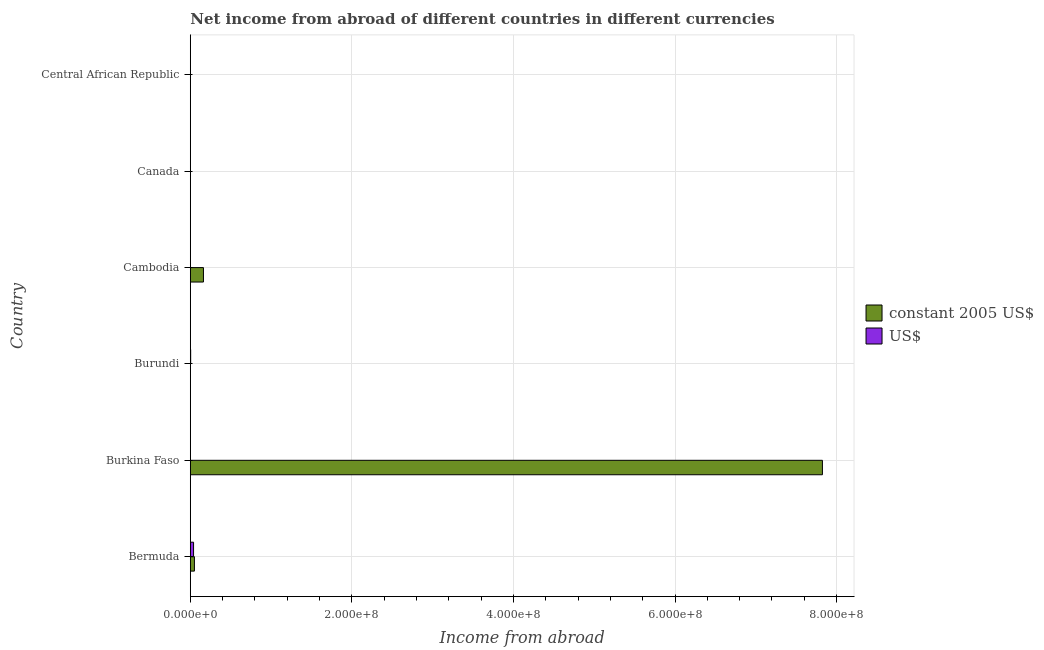Are the number of bars on each tick of the Y-axis equal?
Provide a short and direct response. No. How many bars are there on the 3rd tick from the top?
Provide a succinct answer. 1. What is the income from abroad in us$ in Burundi?
Offer a very short reply. 4.65e+05. Across all countries, what is the maximum income from abroad in constant 2005 us$?
Keep it short and to the point. 7.82e+08. In which country was the income from abroad in us$ maximum?
Provide a short and direct response. Bermuda. What is the total income from abroad in us$ in the graph?
Give a very brief answer. 4.51e+06. What is the difference between the income from abroad in us$ in Bermuda and that in Burundi?
Provide a short and direct response. 3.58e+06. What is the average income from abroad in constant 2005 us$ per country?
Provide a short and direct response. 1.34e+08. What is the difference between the income from abroad in constant 2005 us$ and income from abroad in us$ in Bermuda?
Offer a very short reply. 1.05e+06. What is the difference between the highest and the second highest income from abroad in constant 2005 us$?
Offer a terse response. 7.66e+08. What is the difference between the highest and the lowest income from abroad in us$?
Ensure brevity in your answer.  4.05e+06. Are the values on the major ticks of X-axis written in scientific E-notation?
Your answer should be very brief. Yes. Does the graph contain grids?
Keep it short and to the point. Yes. Where does the legend appear in the graph?
Your answer should be very brief. Center right. What is the title of the graph?
Offer a terse response. Net income from abroad of different countries in different currencies. What is the label or title of the X-axis?
Your answer should be compact. Income from abroad. What is the label or title of the Y-axis?
Your answer should be very brief. Country. What is the Income from abroad in constant 2005 US$ in Bermuda?
Your answer should be very brief. 5.10e+06. What is the Income from abroad of US$ in Bermuda?
Ensure brevity in your answer.  4.05e+06. What is the Income from abroad of constant 2005 US$ in Burkina Faso?
Give a very brief answer. 7.82e+08. What is the Income from abroad in US$ in Burkina Faso?
Offer a very short reply. 0. What is the Income from abroad in constant 2005 US$ in Burundi?
Give a very brief answer. 0. What is the Income from abroad in US$ in Burundi?
Provide a short and direct response. 4.65e+05. What is the Income from abroad in constant 2005 US$ in Cambodia?
Your answer should be very brief. 1.63e+07. What is the Income from abroad of US$ in Cambodia?
Offer a terse response. 0. What is the Income from abroad in constant 2005 US$ in Central African Republic?
Provide a succinct answer. 0. Across all countries, what is the maximum Income from abroad of constant 2005 US$?
Give a very brief answer. 7.82e+08. Across all countries, what is the maximum Income from abroad of US$?
Offer a terse response. 4.05e+06. Across all countries, what is the minimum Income from abroad of constant 2005 US$?
Give a very brief answer. 0. What is the total Income from abroad of constant 2005 US$ in the graph?
Offer a terse response. 8.04e+08. What is the total Income from abroad of US$ in the graph?
Your answer should be compact. 4.51e+06. What is the difference between the Income from abroad of constant 2005 US$ in Bermuda and that in Burkina Faso?
Your answer should be compact. -7.77e+08. What is the difference between the Income from abroad in US$ in Bermuda and that in Burundi?
Keep it short and to the point. 3.58e+06. What is the difference between the Income from abroad in constant 2005 US$ in Bermuda and that in Cambodia?
Provide a short and direct response. -1.12e+07. What is the difference between the Income from abroad in constant 2005 US$ in Burkina Faso and that in Cambodia?
Give a very brief answer. 7.66e+08. What is the difference between the Income from abroad of constant 2005 US$ in Bermuda and the Income from abroad of US$ in Burundi?
Ensure brevity in your answer.  4.63e+06. What is the difference between the Income from abroad in constant 2005 US$ in Burkina Faso and the Income from abroad in US$ in Burundi?
Your answer should be compact. 7.82e+08. What is the average Income from abroad of constant 2005 US$ per country?
Your answer should be very brief. 1.34e+08. What is the average Income from abroad of US$ per country?
Provide a short and direct response. 7.52e+05. What is the difference between the Income from abroad in constant 2005 US$ and Income from abroad in US$ in Bermuda?
Offer a terse response. 1.05e+06. What is the ratio of the Income from abroad in constant 2005 US$ in Bermuda to that in Burkina Faso?
Offer a very short reply. 0.01. What is the ratio of the Income from abroad in US$ in Bermuda to that in Burundi?
Offer a terse response. 8.7. What is the ratio of the Income from abroad of constant 2005 US$ in Bermuda to that in Cambodia?
Your answer should be very brief. 0.31. What is the ratio of the Income from abroad of constant 2005 US$ in Burkina Faso to that in Cambodia?
Offer a very short reply. 48.05. What is the difference between the highest and the second highest Income from abroad of constant 2005 US$?
Keep it short and to the point. 7.66e+08. What is the difference between the highest and the lowest Income from abroad of constant 2005 US$?
Offer a very short reply. 7.82e+08. What is the difference between the highest and the lowest Income from abroad in US$?
Keep it short and to the point. 4.05e+06. 